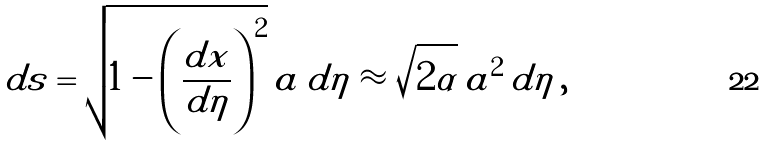<formula> <loc_0><loc_0><loc_500><loc_500>d s = \sqrt { 1 - \left ( \frac { d x } { d \eta } \right ) ^ { 2 } } \, a \, d \eta \approx \sqrt { 2 \alpha } \, a ^ { 2 } \, d \eta \, ,</formula> 